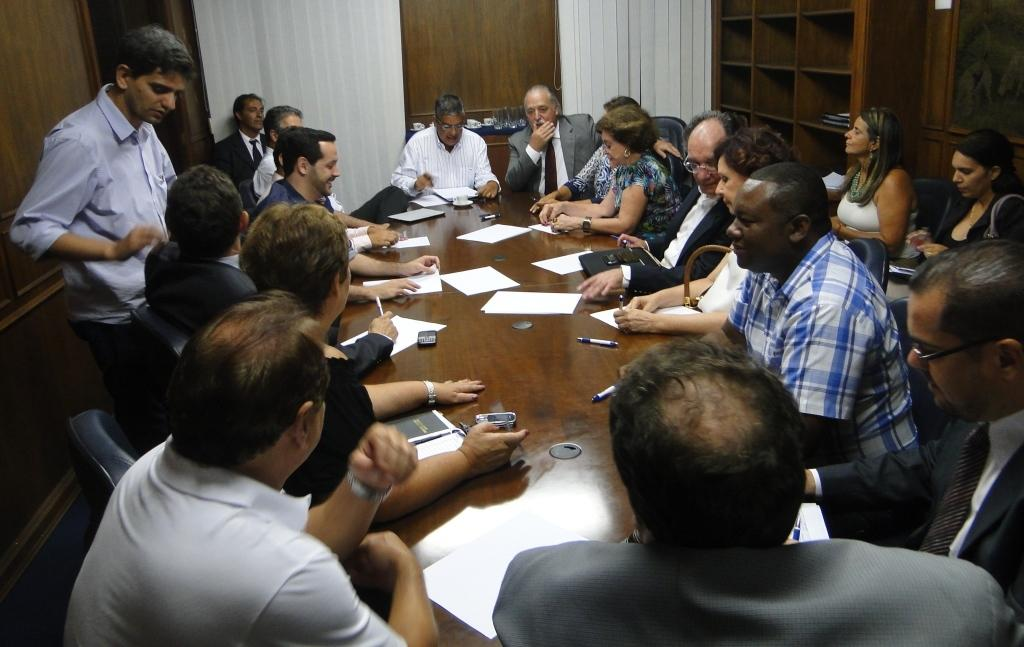What are the people in the image doing? There is a group of people sitting on chairs in the image. Can you describe the man in the image? There is a man standing on a path in the image. What can be seen in the background of the image? There are rocks and a wooden wall visible in the background of the image. What type of riddle is the man trying to solve on the path in the image? There is no riddle present in the image; the man is simply standing on a path. 